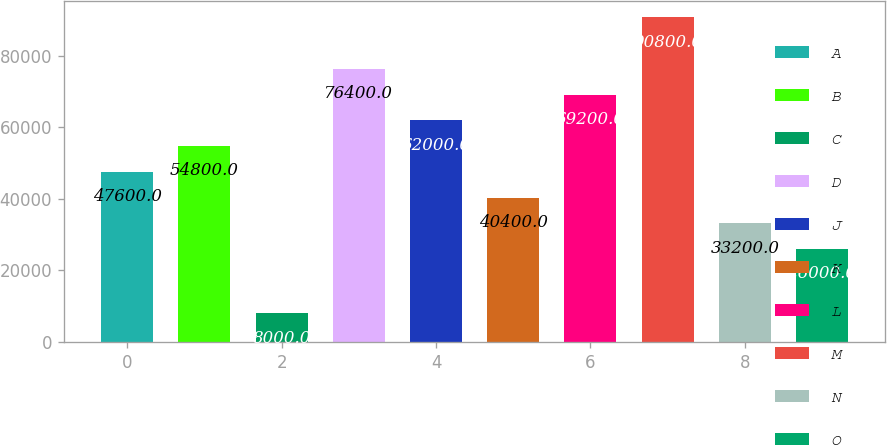<chart> <loc_0><loc_0><loc_500><loc_500><bar_chart><fcel>A<fcel>B<fcel>C<fcel>D<fcel>J<fcel>K<fcel>L<fcel>M<fcel>N<fcel>O<nl><fcel>47600<fcel>54800<fcel>8000<fcel>76400<fcel>62000<fcel>40400<fcel>69200<fcel>90800<fcel>33200<fcel>26000<nl></chart> 